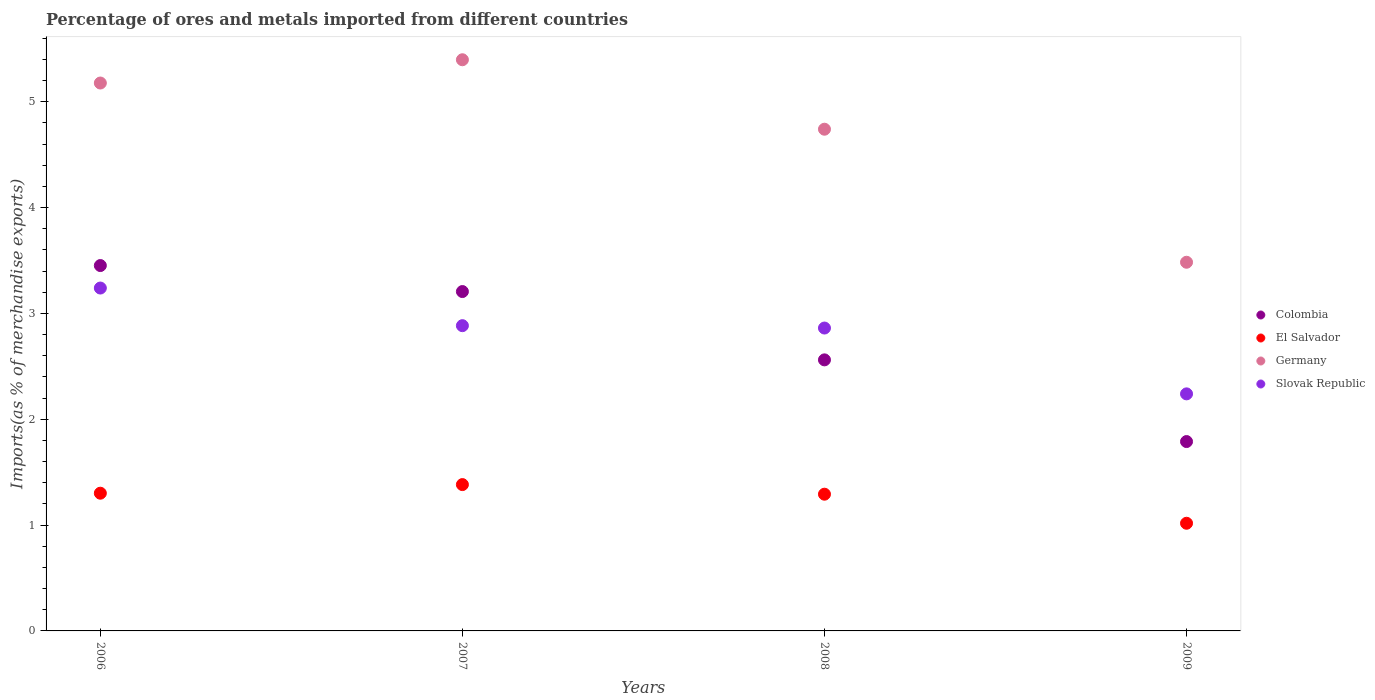How many different coloured dotlines are there?
Offer a very short reply. 4. Is the number of dotlines equal to the number of legend labels?
Provide a succinct answer. Yes. What is the percentage of imports to different countries in Slovak Republic in 2008?
Ensure brevity in your answer.  2.86. Across all years, what is the maximum percentage of imports to different countries in Germany?
Your answer should be very brief. 5.4. Across all years, what is the minimum percentage of imports to different countries in Germany?
Your response must be concise. 3.48. In which year was the percentage of imports to different countries in Germany minimum?
Your answer should be very brief. 2009. What is the total percentage of imports to different countries in Germany in the graph?
Provide a short and direct response. 18.8. What is the difference between the percentage of imports to different countries in El Salvador in 2006 and that in 2009?
Offer a very short reply. 0.28. What is the difference between the percentage of imports to different countries in Germany in 2006 and the percentage of imports to different countries in Colombia in 2009?
Offer a very short reply. 3.39. What is the average percentage of imports to different countries in El Salvador per year?
Give a very brief answer. 1.25. In the year 2007, what is the difference between the percentage of imports to different countries in Slovak Republic and percentage of imports to different countries in Colombia?
Offer a terse response. -0.32. What is the ratio of the percentage of imports to different countries in Colombia in 2006 to that in 2008?
Ensure brevity in your answer.  1.35. What is the difference between the highest and the second highest percentage of imports to different countries in El Salvador?
Make the answer very short. 0.08. What is the difference between the highest and the lowest percentage of imports to different countries in Germany?
Your response must be concise. 1.91. In how many years, is the percentage of imports to different countries in Slovak Republic greater than the average percentage of imports to different countries in Slovak Republic taken over all years?
Your response must be concise. 3. Is it the case that in every year, the sum of the percentage of imports to different countries in Colombia and percentage of imports to different countries in El Salvador  is greater than the sum of percentage of imports to different countries in Slovak Republic and percentage of imports to different countries in Germany?
Make the answer very short. No. Is the percentage of imports to different countries in Slovak Republic strictly greater than the percentage of imports to different countries in Germany over the years?
Give a very brief answer. No. Is the percentage of imports to different countries in Slovak Republic strictly less than the percentage of imports to different countries in Colombia over the years?
Give a very brief answer. No. How many dotlines are there?
Offer a terse response. 4. How many years are there in the graph?
Give a very brief answer. 4. Does the graph contain any zero values?
Keep it short and to the point. No. What is the title of the graph?
Ensure brevity in your answer.  Percentage of ores and metals imported from different countries. Does "Lao PDR" appear as one of the legend labels in the graph?
Your answer should be very brief. No. What is the label or title of the Y-axis?
Keep it short and to the point. Imports(as % of merchandise exports). What is the Imports(as % of merchandise exports) of Colombia in 2006?
Keep it short and to the point. 3.45. What is the Imports(as % of merchandise exports) in El Salvador in 2006?
Your answer should be compact. 1.3. What is the Imports(as % of merchandise exports) in Germany in 2006?
Give a very brief answer. 5.18. What is the Imports(as % of merchandise exports) of Slovak Republic in 2006?
Offer a terse response. 3.24. What is the Imports(as % of merchandise exports) in Colombia in 2007?
Your response must be concise. 3.21. What is the Imports(as % of merchandise exports) in El Salvador in 2007?
Your answer should be very brief. 1.38. What is the Imports(as % of merchandise exports) of Germany in 2007?
Offer a terse response. 5.4. What is the Imports(as % of merchandise exports) in Slovak Republic in 2007?
Provide a short and direct response. 2.88. What is the Imports(as % of merchandise exports) in Colombia in 2008?
Your response must be concise. 2.56. What is the Imports(as % of merchandise exports) of El Salvador in 2008?
Your answer should be very brief. 1.29. What is the Imports(as % of merchandise exports) in Germany in 2008?
Ensure brevity in your answer.  4.74. What is the Imports(as % of merchandise exports) of Slovak Republic in 2008?
Your answer should be very brief. 2.86. What is the Imports(as % of merchandise exports) in Colombia in 2009?
Keep it short and to the point. 1.79. What is the Imports(as % of merchandise exports) in El Salvador in 2009?
Your response must be concise. 1.02. What is the Imports(as % of merchandise exports) of Germany in 2009?
Offer a very short reply. 3.48. What is the Imports(as % of merchandise exports) in Slovak Republic in 2009?
Make the answer very short. 2.24. Across all years, what is the maximum Imports(as % of merchandise exports) in Colombia?
Your response must be concise. 3.45. Across all years, what is the maximum Imports(as % of merchandise exports) in El Salvador?
Your answer should be very brief. 1.38. Across all years, what is the maximum Imports(as % of merchandise exports) in Germany?
Ensure brevity in your answer.  5.4. Across all years, what is the maximum Imports(as % of merchandise exports) of Slovak Republic?
Offer a very short reply. 3.24. Across all years, what is the minimum Imports(as % of merchandise exports) of Colombia?
Your answer should be compact. 1.79. Across all years, what is the minimum Imports(as % of merchandise exports) in El Salvador?
Your answer should be compact. 1.02. Across all years, what is the minimum Imports(as % of merchandise exports) in Germany?
Provide a short and direct response. 3.48. Across all years, what is the minimum Imports(as % of merchandise exports) in Slovak Republic?
Provide a succinct answer. 2.24. What is the total Imports(as % of merchandise exports) of Colombia in the graph?
Ensure brevity in your answer.  11.01. What is the total Imports(as % of merchandise exports) in El Salvador in the graph?
Make the answer very short. 4.99. What is the total Imports(as % of merchandise exports) in Germany in the graph?
Ensure brevity in your answer.  18.8. What is the total Imports(as % of merchandise exports) of Slovak Republic in the graph?
Offer a terse response. 11.22. What is the difference between the Imports(as % of merchandise exports) of Colombia in 2006 and that in 2007?
Keep it short and to the point. 0.25. What is the difference between the Imports(as % of merchandise exports) in El Salvador in 2006 and that in 2007?
Your response must be concise. -0.08. What is the difference between the Imports(as % of merchandise exports) in Germany in 2006 and that in 2007?
Give a very brief answer. -0.22. What is the difference between the Imports(as % of merchandise exports) of Slovak Republic in 2006 and that in 2007?
Your answer should be compact. 0.36. What is the difference between the Imports(as % of merchandise exports) of Colombia in 2006 and that in 2008?
Ensure brevity in your answer.  0.89. What is the difference between the Imports(as % of merchandise exports) in El Salvador in 2006 and that in 2008?
Make the answer very short. 0.01. What is the difference between the Imports(as % of merchandise exports) of Germany in 2006 and that in 2008?
Keep it short and to the point. 0.44. What is the difference between the Imports(as % of merchandise exports) in Slovak Republic in 2006 and that in 2008?
Keep it short and to the point. 0.38. What is the difference between the Imports(as % of merchandise exports) of Colombia in 2006 and that in 2009?
Your answer should be compact. 1.66. What is the difference between the Imports(as % of merchandise exports) of El Salvador in 2006 and that in 2009?
Provide a succinct answer. 0.28. What is the difference between the Imports(as % of merchandise exports) in Germany in 2006 and that in 2009?
Provide a succinct answer. 1.69. What is the difference between the Imports(as % of merchandise exports) in Colombia in 2007 and that in 2008?
Your answer should be very brief. 0.65. What is the difference between the Imports(as % of merchandise exports) in El Salvador in 2007 and that in 2008?
Provide a succinct answer. 0.09. What is the difference between the Imports(as % of merchandise exports) in Germany in 2007 and that in 2008?
Make the answer very short. 0.66. What is the difference between the Imports(as % of merchandise exports) in Slovak Republic in 2007 and that in 2008?
Give a very brief answer. 0.02. What is the difference between the Imports(as % of merchandise exports) of Colombia in 2007 and that in 2009?
Your response must be concise. 1.42. What is the difference between the Imports(as % of merchandise exports) of El Salvador in 2007 and that in 2009?
Give a very brief answer. 0.37. What is the difference between the Imports(as % of merchandise exports) of Germany in 2007 and that in 2009?
Keep it short and to the point. 1.91. What is the difference between the Imports(as % of merchandise exports) in Slovak Republic in 2007 and that in 2009?
Ensure brevity in your answer.  0.64. What is the difference between the Imports(as % of merchandise exports) in Colombia in 2008 and that in 2009?
Make the answer very short. 0.77. What is the difference between the Imports(as % of merchandise exports) in El Salvador in 2008 and that in 2009?
Offer a terse response. 0.27. What is the difference between the Imports(as % of merchandise exports) in Germany in 2008 and that in 2009?
Provide a short and direct response. 1.26. What is the difference between the Imports(as % of merchandise exports) of Slovak Republic in 2008 and that in 2009?
Provide a succinct answer. 0.62. What is the difference between the Imports(as % of merchandise exports) in Colombia in 2006 and the Imports(as % of merchandise exports) in El Salvador in 2007?
Give a very brief answer. 2.07. What is the difference between the Imports(as % of merchandise exports) in Colombia in 2006 and the Imports(as % of merchandise exports) in Germany in 2007?
Offer a terse response. -1.94. What is the difference between the Imports(as % of merchandise exports) in Colombia in 2006 and the Imports(as % of merchandise exports) in Slovak Republic in 2007?
Keep it short and to the point. 0.57. What is the difference between the Imports(as % of merchandise exports) in El Salvador in 2006 and the Imports(as % of merchandise exports) in Germany in 2007?
Your response must be concise. -4.1. What is the difference between the Imports(as % of merchandise exports) of El Salvador in 2006 and the Imports(as % of merchandise exports) of Slovak Republic in 2007?
Offer a very short reply. -1.58. What is the difference between the Imports(as % of merchandise exports) in Germany in 2006 and the Imports(as % of merchandise exports) in Slovak Republic in 2007?
Offer a terse response. 2.29. What is the difference between the Imports(as % of merchandise exports) in Colombia in 2006 and the Imports(as % of merchandise exports) in El Salvador in 2008?
Provide a short and direct response. 2.16. What is the difference between the Imports(as % of merchandise exports) of Colombia in 2006 and the Imports(as % of merchandise exports) of Germany in 2008?
Your answer should be very brief. -1.29. What is the difference between the Imports(as % of merchandise exports) of Colombia in 2006 and the Imports(as % of merchandise exports) of Slovak Republic in 2008?
Provide a succinct answer. 0.59. What is the difference between the Imports(as % of merchandise exports) in El Salvador in 2006 and the Imports(as % of merchandise exports) in Germany in 2008?
Give a very brief answer. -3.44. What is the difference between the Imports(as % of merchandise exports) in El Salvador in 2006 and the Imports(as % of merchandise exports) in Slovak Republic in 2008?
Give a very brief answer. -1.56. What is the difference between the Imports(as % of merchandise exports) of Germany in 2006 and the Imports(as % of merchandise exports) of Slovak Republic in 2008?
Your answer should be very brief. 2.31. What is the difference between the Imports(as % of merchandise exports) in Colombia in 2006 and the Imports(as % of merchandise exports) in El Salvador in 2009?
Make the answer very short. 2.43. What is the difference between the Imports(as % of merchandise exports) in Colombia in 2006 and the Imports(as % of merchandise exports) in Germany in 2009?
Your response must be concise. -0.03. What is the difference between the Imports(as % of merchandise exports) of Colombia in 2006 and the Imports(as % of merchandise exports) of Slovak Republic in 2009?
Provide a succinct answer. 1.21. What is the difference between the Imports(as % of merchandise exports) of El Salvador in 2006 and the Imports(as % of merchandise exports) of Germany in 2009?
Your answer should be compact. -2.18. What is the difference between the Imports(as % of merchandise exports) in El Salvador in 2006 and the Imports(as % of merchandise exports) in Slovak Republic in 2009?
Make the answer very short. -0.94. What is the difference between the Imports(as % of merchandise exports) of Germany in 2006 and the Imports(as % of merchandise exports) of Slovak Republic in 2009?
Provide a succinct answer. 2.94. What is the difference between the Imports(as % of merchandise exports) of Colombia in 2007 and the Imports(as % of merchandise exports) of El Salvador in 2008?
Provide a short and direct response. 1.91. What is the difference between the Imports(as % of merchandise exports) of Colombia in 2007 and the Imports(as % of merchandise exports) of Germany in 2008?
Offer a terse response. -1.53. What is the difference between the Imports(as % of merchandise exports) in Colombia in 2007 and the Imports(as % of merchandise exports) in Slovak Republic in 2008?
Your response must be concise. 0.34. What is the difference between the Imports(as % of merchandise exports) of El Salvador in 2007 and the Imports(as % of merchandise exports) of Germany in 2008?
Make the answer very short. -3.36. What is the difference between the Imports(as % of merchandise exports) of El Salvador in 2007 and the Imports(as % of merchandise exports) of Slovak Republic in 2008?
Provide a succinct answer. -1.48. What is the difference between the Imports(as % of merchandise exports) in Germany in 2007 and the Imports(as % of merchandise exports) in Slovak Republic in 2008?
Offer a terse response. 2.53. What is the difference between the Imports(as % of merchandise exports) of Colombia in 2007 and the Imports(as % of merchandise exports) of El Salvador in 2009?
Keep it short and to the point. 2.19. What is the difference between the Imports(as % of merchandise exports) in Colombia in 2007 and the Imports(as % of merchandise exports) in Germany in 2009?
Your answer should be compact. -0.28. What is the difference between the Imports(as % of merchandise exports) in Colombia in 2007 and the Imports(as % of merchandise exports) in Slovak Republic in 2009?
Your response must be concise. 0.97. What is the difference between the Imports(as % of merchandise exports) in El Salvador in 2007 and the Imports(as % of merchandise exports) in Germany in 2009?
Provide a succinct answer. -2.1. What is the difference between the Imports(as % of merchandise exports) of El Salvador in 2007 and the Imports(as % of merchandise exports) of Slovak Republic in 2009?
Offer a terse response. -0.86. What is the difference between the Imports(as % of merchandise exports) in Germany in 2007 and the Imports(as % of merchandise exports) in Slovak Republic in 2009?
Your answer should be very brief. 3.16. What is the difference between the Imports(as % of merchandise exports) of Colombia in 2008 and the Imports(as % of merchandise exports) of El Salvador in 2009?
Provide a succinct answer. 1.54. What is the difference between the Imports(as % of merchandise exports) in Colombia in 2008 and the Imports(as % of merchandise exports) in Germany in 2009?
Ensure brevity in your answer.  -0.92. What is the difference between the Imports(as % of merchandise exports) of Colombia in 2008 and the Imports(as % of merchandise exports) of Slovak Republic in 2009?
Ensure brevity in your answer.  0.32. What is the difference between the Imports(as % of merchandise exports) of El Salvador in 2008 and the Imports(as % of merchandise exports) of Germany in 2009?
Offer a very short reply. -2.19. What is the difference between the Imports(as % of merchandise exports) of El Salvador in 2008 and the Imports(as % of merchandise exports) of Slovak Republic in 2009?
Give a very brief answer. -0.95. What is the difference between the Imports(as % of merchandise exports) in Germany in 2008 and the Imports(as % of merchandise exports) in Slovak Republic in 2009?
Your answer should be compact. 2.5. What is the average Imports(as % of merchandise exports) in Colombia per year?
Give a very brief answer. 2.75. What is the average Imports(as % of merchandise exports) in El Salvador per year?
Provide a succinct answer. 1.25. What is the average Imports(as % of merchandise exports) in Germany per year?
Provide a short and direct response. 4.7. What is the average Imports(as % of merchandise exports) of Slovak Republic per year?
Provide a short and direct response. 2.81. In the year 2006, what is the difference between the Imports(as % of merchandise exports) of Colombia and Imports(as % of merchandise exports) of El Salvador?
Your answer should be very brief. 2.15. In the year 2006, what is the difference between the Imports(as % of merchandise exports) of Colombia and Imports(as % of merchandise exports) of Germany?
Offer a very short reply. -1.72. In the year 2006, what is the difference between the Imports(as % of merchandise exports) of Colombia and Imports(as % of merchandise exports) of Slovak Republic?
Provide a succinct answer. 0.21. In the year 2006, what is the difference between the Imports(as % of merchandise exports) in El Salvador and Imports(as % of merchandise exports) in Germany?
Give a very brief answer. -3.88. In the year 2006, what is the difference between the Imports(as % of merchandise exports) in El Salvador and Imports(as % of merchandise exports) in Slovak Republic?
Keep it short and to the point. -1.94. In the year 2006, what is the difference between the Imports(as % of merchandise exports) of Germany and Imports(as % of merchandise exports) of Slovak Republic?
Provide a succinct answer. 1.94. In the year 2007, what is the difference between the Imports(as % of merchandise exports) in Colombia and Imports(as % of merchandise exports) in El Salvador?
Your response must be concise. 1.82. In the year 2007, what is the difference between the Imports(as % of merchandise exports) of Colombia and Imports(as % of merchandise exports) of Germany?
Your answer should be very brief. -2.19. In the year 2007, what is the difference between the Imports(as % of merchandise exports) in Colombia and Imports(as % of merchandise exports) in Slovak Republic?
Your answer should be compact. 0.32. In the year 2007, what is the difference between the Imports(as % of merchandise exports) in El Salvador and Imports(as % of merchandise exports) in Germany?
Keep it short and to the point. -4.01. In the year 2007, what is the difference between the Imports(as % of merchandise exports) of El Salvador and Imports(as % of merchandise exports) of Slovak Republic?
Make the answer very short. -1.5. In the year 2007, what is the difference between the Imports(as % of merchandise exports) of Germany and Imports(as % of merchandise exports) of Slovak Republic?
Keep it short and to the point. 2.51. In the year 2008, what is the difference between the Imports(as % of merchandise exports) of Colombia and Imports(as % of merchandise exports) of El Salvador?
Provide a short and direct response. 1.27. In the year 2008, what is the difference between the Imports(as % of merchandise exports) of Colombia and Imports(as % of merchandise exports) of Germany?
Provide a succinct answer. -2.18. In the year 2008, what is the difference between the Imports(as % of merchandise exports) in Colombia and Imports(as % of merchandise exports) in Slovak Republic?
Keep it short and to the point. -0.3. In the year 2008, what is the difference between the Imports(as % of merchandise exports) of El Salvador and Imports(as % of merchandise exports) of Germany?
Give a very brief answer. -3.45. In the year 2008, what is the difference between the Imports(as % of merchandise exports) of El Salvador and Imports(as % of merchandise exports) of Slovak Republic?
Your answer should be very brief. -1.57. In the year 2008, what is the difference between the Imports(as % of merchandise exports) in Germany and Imports(as % of merchandise exports) in Slovak Republic?
Provide a succinct answer. 1.88. In the year 2009, what is the difference between the Imports(as % of merchandise exports) in Colombia and Imports(as % of merchandise exports) in El Salvador?
Your answer should be compact. 0.77. In the year 2009, what is the difference between the Imports(as % of merchandise exports) in Colombia and Imports(as % of merchandise exports) in Germany?
Offer a very short reply. -1.69. In the year 2009, what is the difference between the Imports(as % of merchandise exports) in Colombia and Imports(as % of merchandise exports) in Slovak Republic?
Provide a short and direct response. -0.45. In the year 2009, what is the difference between the Imports(as % of merchandise exports) in El Salvador and Imports(as % of merchandise exports) in Germany?
Offer a very short reply. -2.47. In the year 2009, what is the difference between the Imports(as % of merchandise exports) of El Salvador and Imports(as % of merchandise exports) of Slovak Republic?
Your answer should be very brief. -1.22. In the year 2009, what is the difference between the Imports(as % of merchandise exports) in Germany and Imports(as % of merchandise exports) in Slovak Republic?
Make the answer very short. 1.24. What is the ratio of the Imports(as % of merchandise exports) of Colombia in 2006 to that in 2007?
Provide a succinct answer. 1.08. What is the ratio of the Imports(as % of merchandise exports) in El Salvador in 2006 to that in 2007?
Your answer should be compact. 0.94. What is the ratio of the Imports(as % of merchandise exports) in Germany in 2006 to that in 2007?
Offer a terse response. 0.96. What is the ratio of the Imports(as % of merchandise exports) in Slovak Republic in 2006 to that in 2007?
Offer a very short reply. 1.12. What is the ratio of the Imports(as % of merchandise exports) in Colombia in 2006 to that in 2008?
Provide a short and direct response. 1.35. What is the ratio of the Imports(as % of merchandise exports) of Germany in 2006 to that in 2008?
Offer a terse response. 1.09. What is the ratio of the Imports(as % of merchandise exports) of Slovak Republic in 2006 to that in 2008?
Offer a very short reply. 1.13. What is the ratio of the Imports(as % of merchandise exports) in Colombia in 2006 to that in 2009?
Your answer should be very brief. 1.93. What is the ratio of the Imports(as % of merchandise exports) in El Salvador in 2006 to that in 2009?
Keep it short and to the point. 1.28. What is the ratio of the Imports(as % of merchandise exports) in Germany in 2006 to that in 2009?
Provide a short and direct response. 1.49. What is the ratio of the Imports(as % of merchandise exports) in Slovak Republic in 2006 to that in 2009?
Make the answer very short. 1.45. What is the ratio of the Imports(as % of merchandise exports) in Colombia in 2007 to that in 2008?
Your response must be concise. 1.25. What is the ratio of the Imports(as % of merchandise exports) in El Salvador in 2007 to that in 2008?
Provide a short and direct response. 1.07. What is the ratio of the Imports(as % of merchandise exports) in Germany in 2007 to that in 2008?
Ensure brevity in your answer.  1.14. What is the ratio of the Imports(as % of merchandise exports) in Slovak Republic in 2007 to that in 2008?
Offer a very short reply. 1.01. What is the ratio of the Imports(as % of merchandise exports) in Colombia in 2007 to that in 2009?
Ensure brevity in your answer.  1.79. What is the ratio of the Imports(as % of merchandise exports) in El Salvador in 2007 to that in 2009?
Your answer should be compact. 1.36. What is the ratio of the Imports(as % of merchandise exports) of Germany in 2007 to that in 2009?
Give a very brief answer. 1.55. What is the ratio of the Imports(as % of merchandise exports) of Slovak Republic in 2007 to that in 2009?
Your answer should be very brief. 1.29. What is the ratio of the Imports(as % of merchandise exports) of Colombia in 2008 to that in 2009?
Provide a succinct answer. 1.43. What is the ratio of the Imports(as % of merchandise exports) in El Salvador in 2008 to that in 2009?
Your answer should be compact. 1.27. What is the ratio of the Imports(as % of merchandise exports) in Germany in 2008 to that in 2009?
Provide a succinct answer. 1.36. What is the ratio of the Imports(as % of merchandise exports) of Slovak Republic in 2008 to that in 2009?
Provide a short and direct response. 1.28. What is the difference between the highest and the second highest Imports(as % of merchandise exports) in Colombia?
Your answer should be compact. 0.25. What is the difference between the highest and the second highest Imports(as % of merchandise exports) of El Salvador?
Offer a terse response. 0.08. What is the difference between the highest and the second highest Imports(as % of merchandise exports) in Germany?
Provide a succinct answer. 0.22. What is the difference between the highest and the second highest Imports(as % of merchandise exports) of Slovak Republic?
Provide a succinct answer. 0.36. What is the difference between the highest and the lowest Imports(as % of merchandise exports) in Colombia?
Your answer should be very brief. 1.66. What is the difference between the highest and the lowest Imports(as % of merchandise exports) in El Salvador?
Your answer should be very brief. 0.37. What is the difference between the highest and the lowest Imports(as % of merchandise exports) of Germany?
Provide a short and direct response. 1.91. 